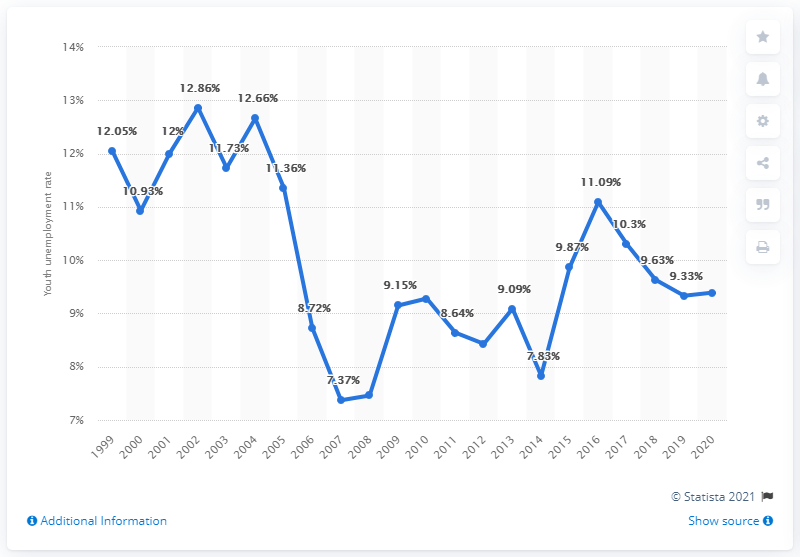Can you describe the trend in youth unemployment in Norway from 1999 to 2020? The trend in youth unemployment in Norway from 1999 to 2020 shows fluctuations, with peaks and troughs. Starting at 10.93% in 1999 it increased to a high of 12.66% in 2002, followed by a decline to 7.37% in 2008. It spiked again in the following years, reaching 11.73% in 2010. After 2010, the rate shows an overall declining trend, reaching 9.39% in 2020. 